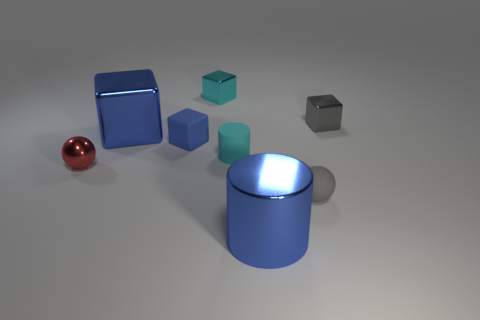Is there any other thing that has the same size as the red ball? Upon closer examination of the image, it appears that none of the objects share the exact dimensions as the red ball. Each object has a unique size and shape, making them all distinct from one another. 